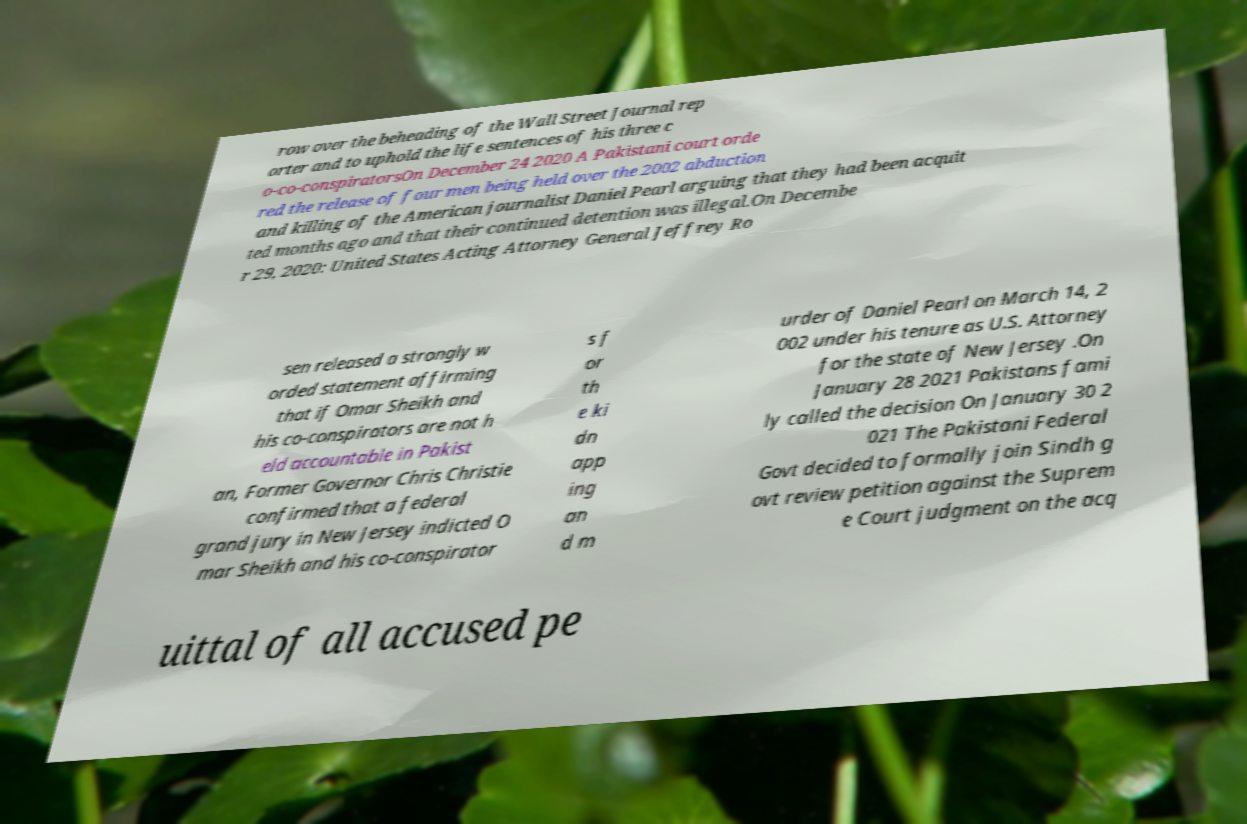Can you read and provide the text displayed in the image?This photo seems to have some interesting text. Can you extract and type it out for me? row over the beheading of the Wall Street Journal rep orter and to uphold the life sentences of his three c o-co-conspiratorsOn December 24 2020 A Pakistani court orde red the release of four men being held over the 2002 abduction and killing of the American journalist Daniel Pearl arguing that they had been acquit ted months ago and that their continued detention was illegal.On Decembe r 29, 2020: United States Acting Attorney General Jeffrey Ro sen released a strongly w orded statement affirming that if Omar Sheikh and his co-conspirators are not h eld accountable in Pakist an, Former Governor Chris Christie confirmed that a federal grand jury in New Jersey indicted O mar Sheikh and his co-conspirator s f or th e ki dn app ing an d m urder of Daniel Pearl on March 14, 2 002 under his tenure as U.S. Attorney for the state of New Jersey .On January 28 2021 Pakistans fami ly called the decision On January 30 2 021 The Pakistani Federal Govt decided to formally join Sindh g ovt review petition against the Suprem e Court judgment on the acq uittal of all accused pe 